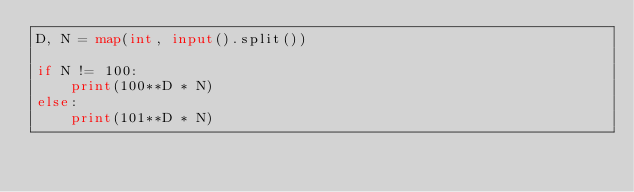Convert code to text. <code><loc_0><loc_0><loc_500><loc_500><_Python_>D, N = map(int, input().split())

if N != 100:
    print(100**D * N)
else:
    print(101**D * N)
</code> 